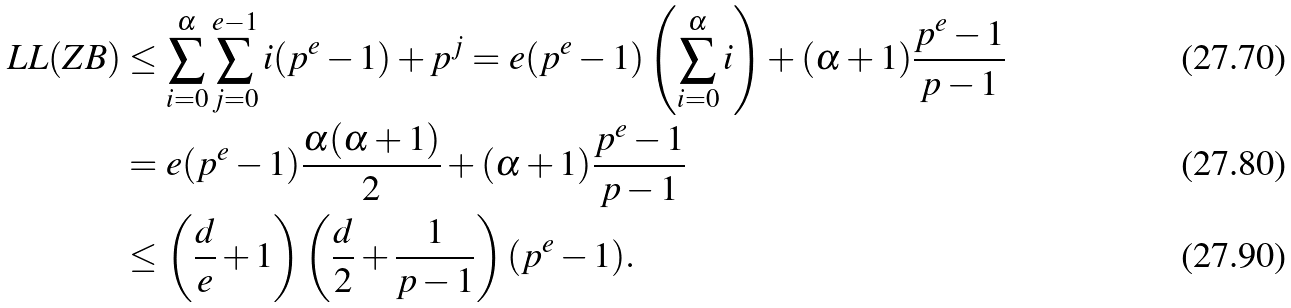Convert formula to latex. <formula><loc_0><loc_0><loc_500><loc_500>L L ( Z B ) & \leq \sum _ { i = 0 } ^ { \alpha } \sum _ { j = 0 } ^ { e - 1 } { i ( p ^ { e } - 1 ) + p ^ { j } } = e ( p ^ { e } - 1 ) \left ( \sum _ { i = 0 } ^ { \alpha } i \right ) + ( \alpha + 1 ) \frac { p ^ { e } - 1 } { p - 1 } \\ & = e ( p ^ { e } - 1 ) \frac { \alpha ( \alpha + 1 ) } { 2 } + ( \alpha + 1 ) \frac { p ^ { e } - 1 } { p - 1 } \\ & \leq \left ( \frac { d } { e } + 1 \right ) \left ( \frac { d } { 2 } + \frac { 1 } { p - 1 } \right ) ( p ^ { e } - 1 ) .</formula> 